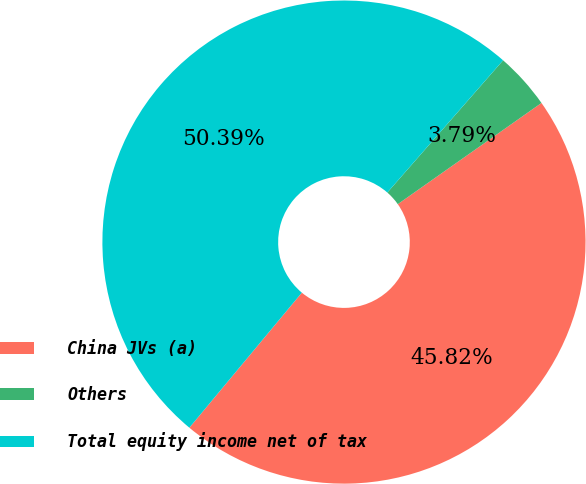Convert chart. <chart><loc_0><loc_0><loc_500><loc_500><pie_chart><fcel>China JVs (a)<fcel>Others<fcel>Total equity income net of tax<nl><fcel>45.82%<fcel>3.79%<fcel>50.39%<nl></chart> 